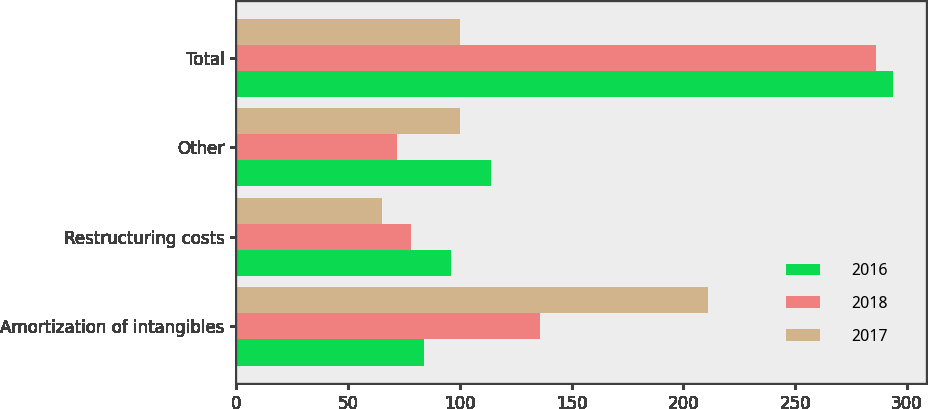<chart> <loc_0><loc_0><loc_500><loc_500><stacked_bar_chart><ecel><fcel>Amortization of intangibles<fcel>Restructuring costs<fcel>Other<fcel>Total<nl><fcel>2016<fcel>84<fcel>96<fcel>114<fcel>294<nl><fcel>2018<fcel>136<fcel>78<fcel>72<fcel>286<nl><fcel>2017<fcel>211<fcel>65<fcel>100<fcel>100<nl></chart> 